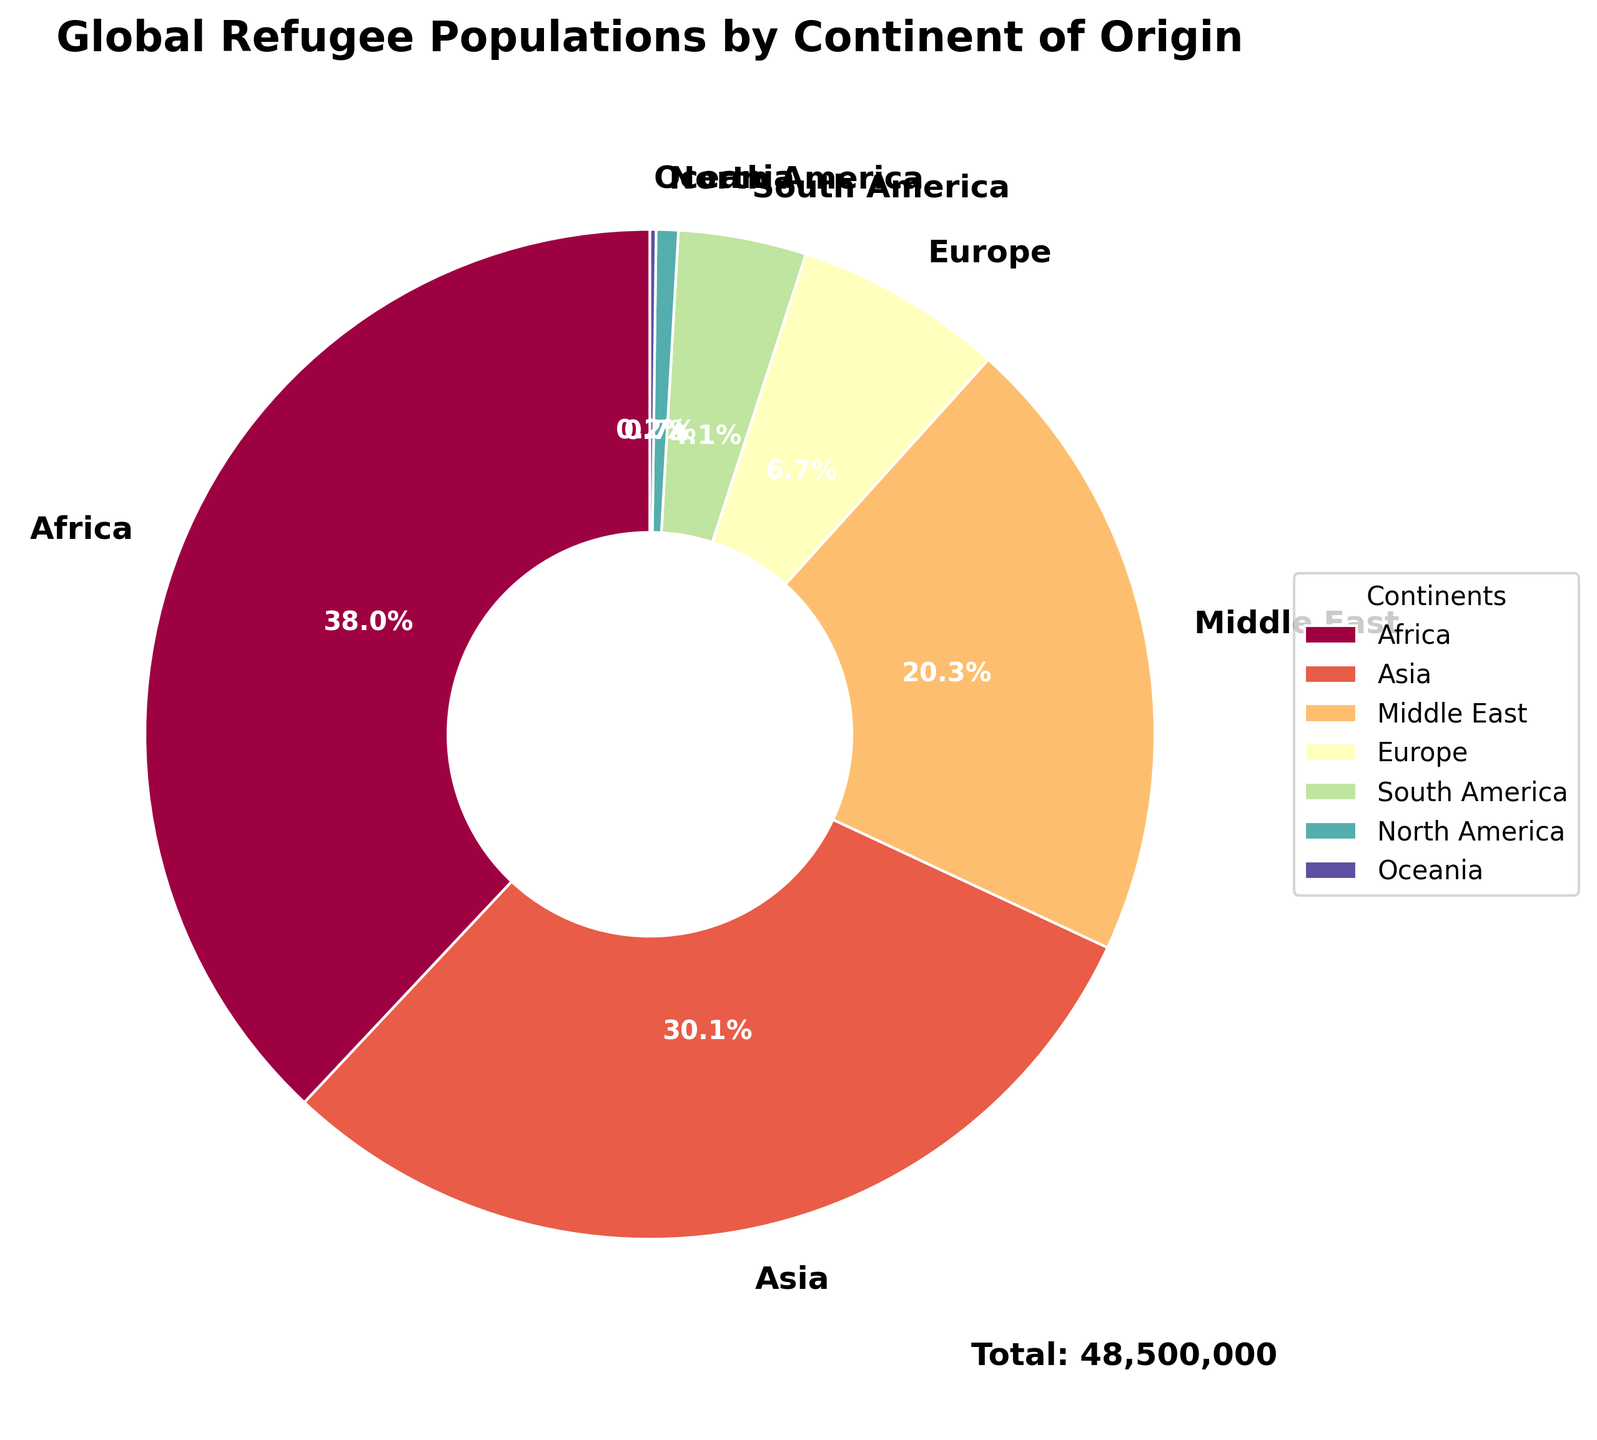What percentage of the world's refugees originate from Africa? The figure shows a pie chart with percentages labeled for each continent. Find the percentage label for Africa.
Answer: 36.5% Between Asia and the Middle East, which continent has more refugees, and by how much? Compare the sizes or the exact refugee numbers for Asia and the Middle East. Subtract the number for the Middle East from that of Asia.
Answer: Asia by 4,864,000 Which continent has the smallest proportion of the global refugee population? Identify the wedge corresponding to the smallest percentage in the pie chart.
Answer: Oceania How many continents have a refugee population of less than 5 million? Observe the chart to count the continents where the percentage converts to a number less than 5 million. Check the legend and match percentage to exact figures if needed.
Answer: 4 What is the combined percentage of refugees from South America and North America? Add the percentage figures for South America and North America as shown in the labels of the pie chart.
Answer: 4.2% If the total number of refugees is 50 million, how many refugees come from Europe? The percentage for Europe is given in the pie chart. Multiply the total number of 50 million by the percentage for Europe. For example, if Europe is 6.5%, then Europe = 50,000,000 * 6.5%.
Answer: 3,250,000 Which two continents combined account for more than half of the global refugee population? Add the largest continents' percentages until the sum exceeds 50%.
Answer: Africa and Asia How does the refugee population in Europe compare to that in South America? Compare the size of the wedges or the percentage labels for Europe and South America to see which is larger.
Answer: Europe is larger What visual attribute is used to distinguish the different continents in the pie chart? Observe the chart and describe the feature used to differentiate each continent, such as color.
Answer: Colors Which continent has nearly the same number of refugees as the Middle East? Compare the refugee numbers for all continents to find one closest to the Middle East.
Answer: Asia 